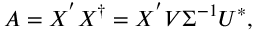<formula> <loc_0><loc_0><loc_500><loc_500>A = X ^ { ^ { \prime } } X ^ { \dag } = X ^ { ^ { \prime } } V \Sigma ^ { - 1 } U ^ { * } ,</formula> 